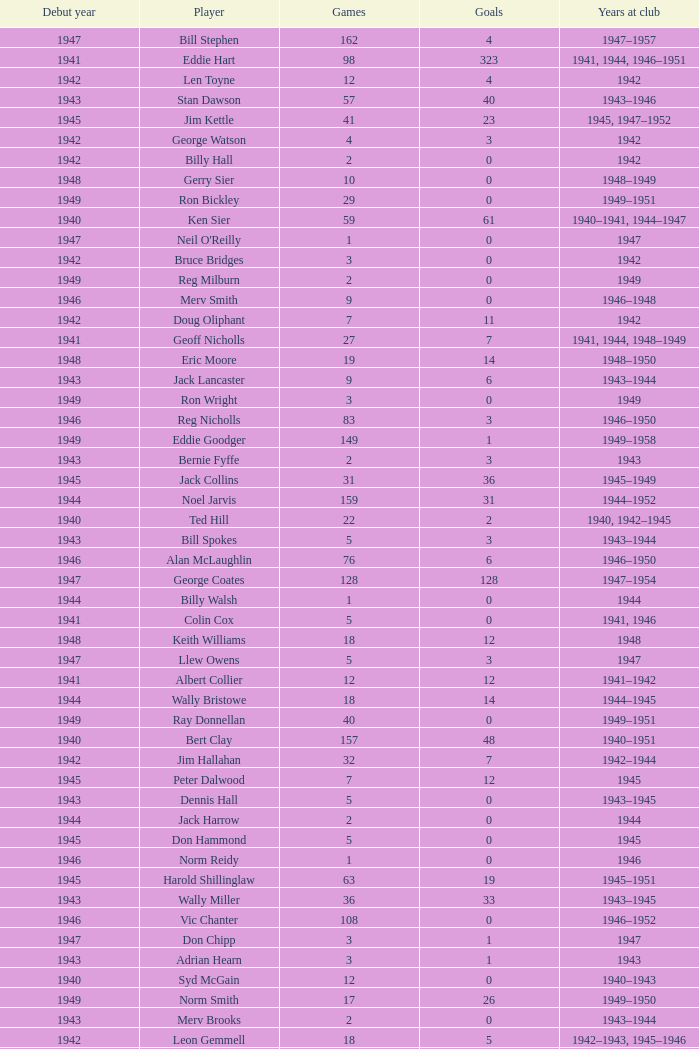Which player debuted before 1943, played for the club in 1942, played less than 12 games, and scored less than 11 goals? Bruce Bridges, George Watson, Reg Hammond, Angie Muller, Leo Hicks, Bernie McVeigh, Billy Hall. 